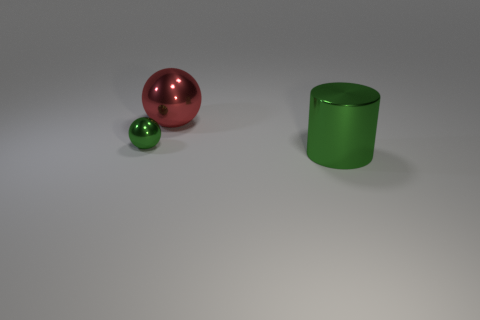Subtract all yellow blocks. How many red cylinders are left? 0 Subtract all large things. Subtract all small green spheres. How many objects are left? 0 Add 2 large red spheres. How many large red spheres are left? 3 Add 1 metal cylinders. How many metal cylinders exist? 2 Add 3 red objects. How many objects exist? 6 Subtract 1 green cylinders. How many objects are left? 2 Subtract all cylinders. How many objects are left? 2 Subtract 1 cylinders. How many cylinders are left? 0 Subtract all red cylinders. Subtract all blue spheres. How many cylinders are left? 1 